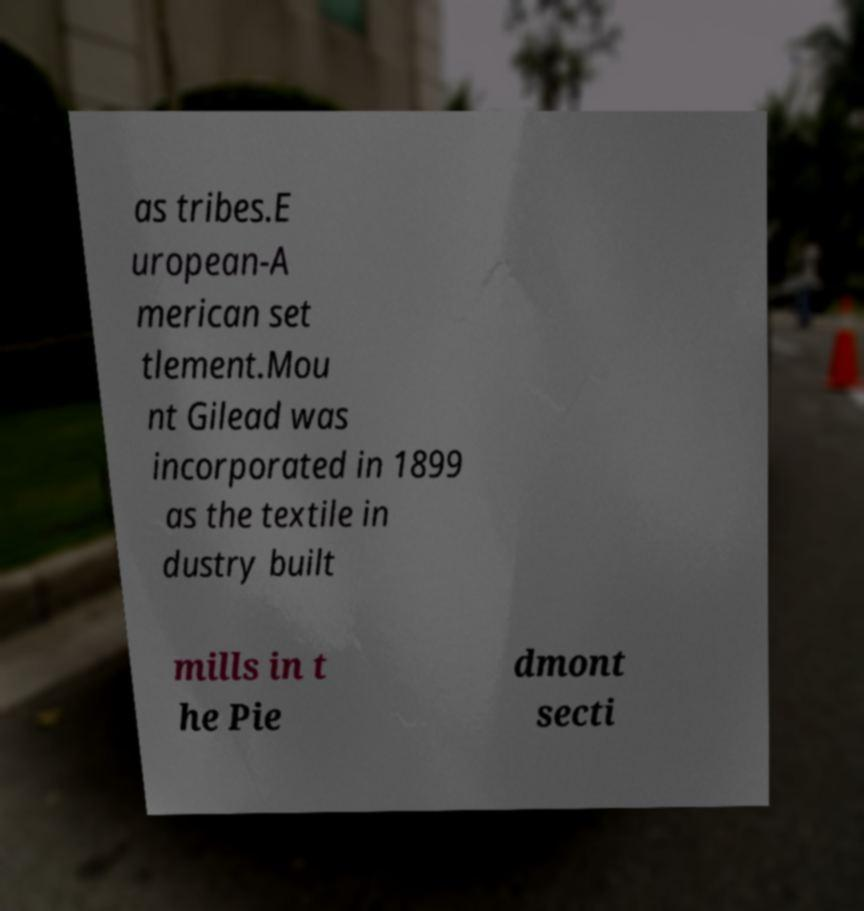Could you extract and type out the text from this image? as tribes.E uropean-A merican set tlement.Mou nt Gilead was incorporated in 1899 as the textile in dustry built mills in t he Pie dmont secti 